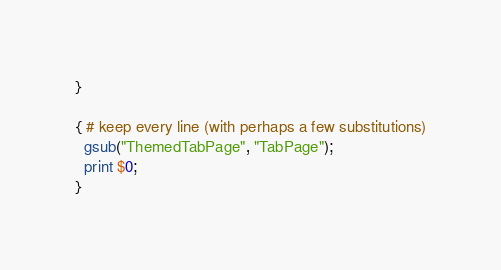<code> <loc_0><loc_0><loc_500><loc_500><_Awk_>}

{ # keep every line (with perhaps a few substitutions)
  gsub("ThemedTabPage", "TabPage");
  print $0;
}
</code> 